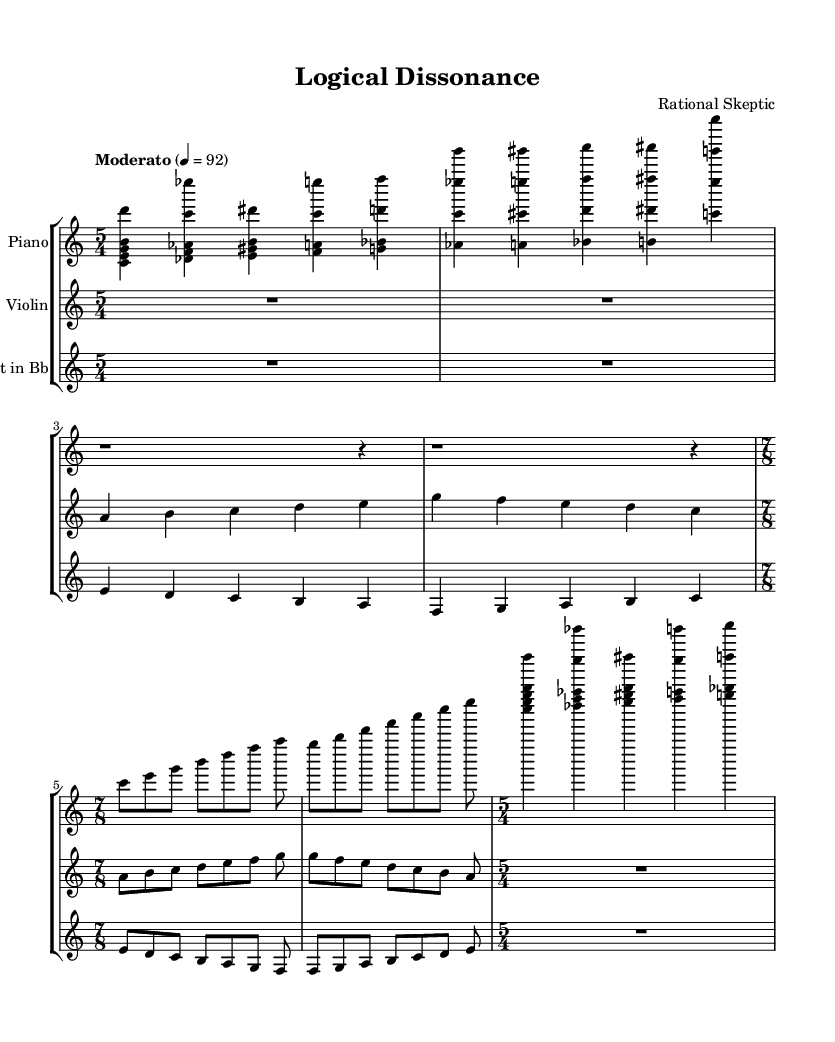What is the time signature of this piece? The time signature at the beginning of the score indicates a 5/4 meter. This means there are five beats per measure, and each quarter note gets one beat.
Answer: 5/4 What is the tempo marking for this composition? The tempo marking indicates "Moderato" at a speed of 92 beats per minute. This suggests a moderately slow pace for the performance.
Answer: Moderato 4 = 92 How many measures are there in the introduction section? By counting the measures in the introduction, which consists of the first section for both Piano and Violin, we can see there are a total of 8 measures.
Answer: 8 In what time signature is the climax section written? The climax section starts with a time signature change to 7/8, indicating a shift in rhythmic grouping to seven eighth notes per measure.
Answer: 7/8 What instruments are included in this score? The score features three instruments: Piano, Violin, and Clarinet in B flat. The parts for each instrument are explicitly labeled at the beginning of the score.
Answer: Piano, Violin, Clarinet in B flat What type of musical structure is evident in the development section? The development section showcases counterpoint, where independent melodic lines are played simultaneously, reflecting a more intricate interrelationship between the instruments.
Answer: Counterpoint How does the conclusion relate to the introduction? The conclusion returns to the initial motif presented in the introduction, signaling a sense of closure and coherence in the composition by revisiting earlier themes.
Answer: Return to initial motif 